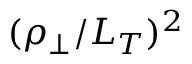Convert formula to latex. <formula><loc_0><loc_0><loc_500><loc_500>( \rho _ { \perp } / L _ { T } ) ^ { 2 }</formula> 